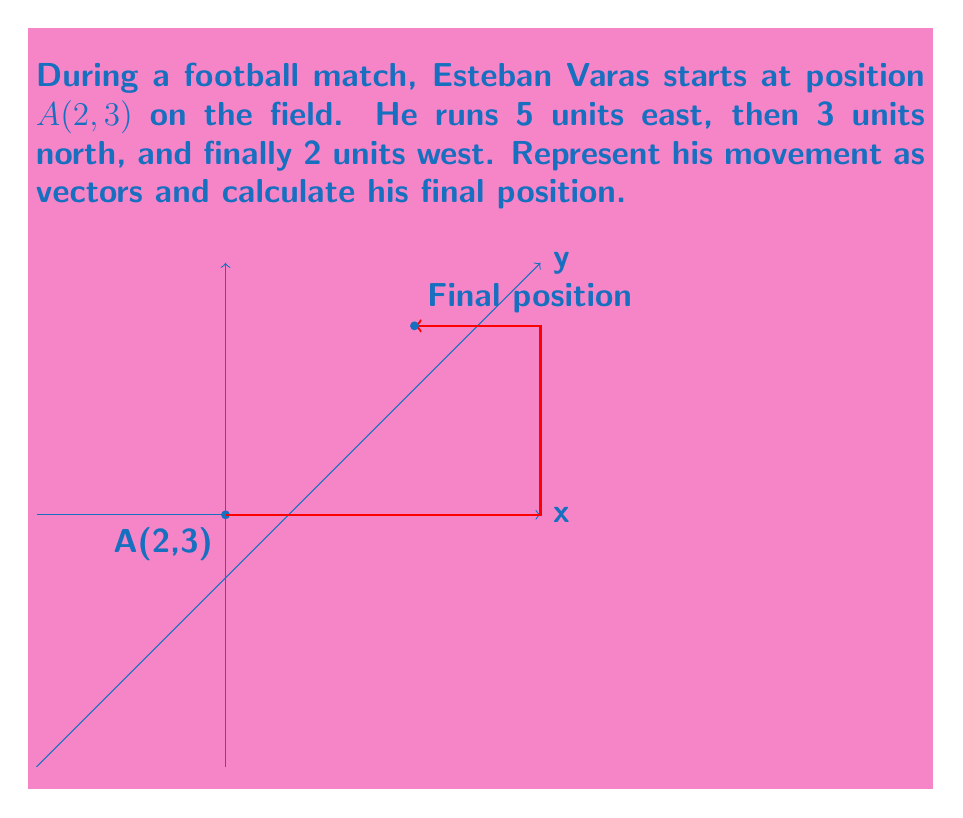Help me with this question. Let's approach this step-by-step:

1) First, we need to represent each movement as a vector:
   - 5 units east: $\vec{v}_1 = \langle 5, 0 \rangle$
   - 3 units north: $\vec{v}_2 = \langle 0, 3 \rangle$
   - 2 units west: $\vec{v}_3 = \langle -2, 0 \rangle$

2) The total displacement vector is the sum of these vectors:
   $$\vec{v}_{total} = \vec{v}_1 + \vec{v}_2 + \vec{v}_3$$

3) Let's add the vectors:
   $$\vec{v}_{total} = \langle 5, 0 \rangle + \langle 0, 3 \rangle + \langle -2, 0 \rangle$$
   $$= \langle 5+0-2, 0+3+0 \rangle = \langle 3, 3 \rangle$$

4) This displacement vector $\langle 3, 3 \rangle$ represents the overall movement from the starting position.

5) To find the final position, we add this displacement to the initial position:
   $$\text{Final position} = A + \vec{v}_{total} = (2, 3) + \langle 3, 3 \rangle = (2+3, 3+3) = (5, 6)$$

Therefore, Esteban Varas' final position is $(5, 6)$.
Answer: $(5, 6)$ 